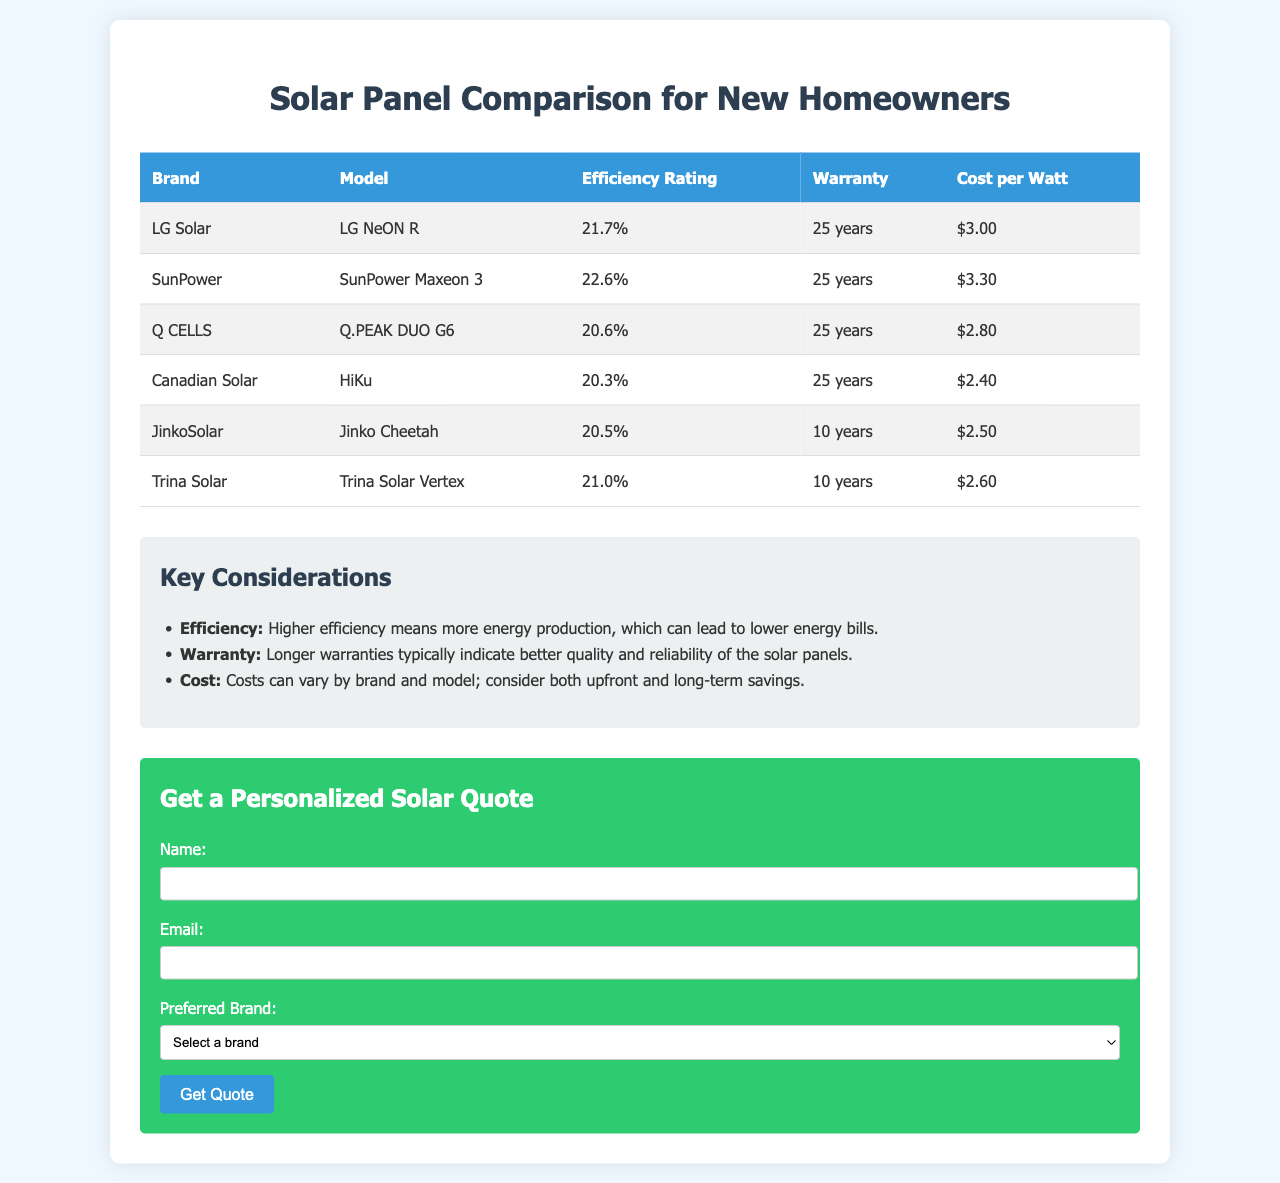what is the efficiency rating of SunPower? The efficiency rating for SunPower Maxeon 3 is mentioned in the table, which is 22.6%.
Answer: 22.6% how many years is the warranty for LG Solar panels? The warranty duration for LG Solar panels (LG NeON R) is listed in the table as 25 years.
Answer: 25 years which brand has the lowest cost per watt? The brand with the lowest cost per watt is identified in the table, which is Canadian Solar at $2.40.
Answer: Canadian Solar what is the efficiency rating of Q CELLS panels? The efficiency rating for Q CELLS Q.PEAK DUO G6 is provided in the table as 20.6%.
Answer: 20.6% how much does JinkoSolar cost per watt? The cost per watt for JinkoSolar (Jinko Cheetah) is specified in the table as $2.50.
Answer: $2.50 which panel has a shorter warranty, JinkoSolar or Trina Solar? The warranty years for JinkoSolar and Trina Solar are compared in the document, with JinkoSolar having 10 years and Trina Solar also having 10 years, making their warranties equal.
Answer: Equal is there a warranty longer than 25 years for any brands? The document lists warranties only up to 25 years, none exceed that duration.
Answer: No which solar panel brand is the most efficient? The table indicates the most efficient brand, which is SunPower Maxeon 3 with an efficiency rating of 22.6%.
Answer: SunPower 